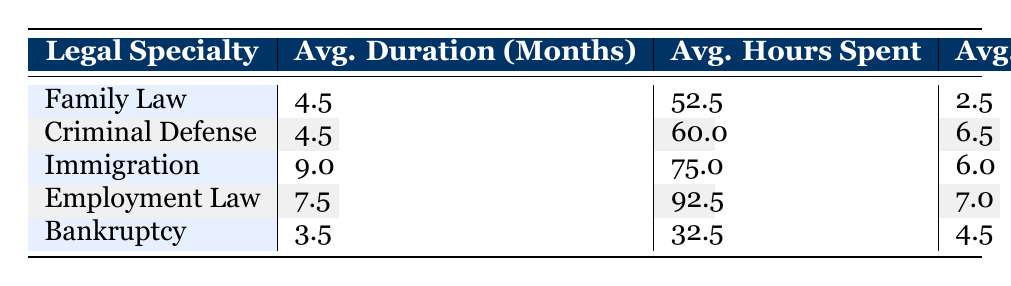What is the average duration of cases in Family Law? There are two Family Law cases. The average duration is calculated by summing their durations (4 + 5 = 9 months) and dividing by the number of cases (9 / 2 = 4.5 months).
Answer: 4.5 months What is the total number of cases handled in Immigration Law? There are two cases listed under Immigration Law: PB003 and PB008, which are the only cases in that specialty. Therefore, the total is 2.
Answer: 2 Which legal specialty has the lowest average hours spent on cases? By examining the average hours spent for each specialty: Family Law (52.5), Criminal Defense (60.0), Immigration (75.0), Employment Law (92.5), and Bankruptcy (32.5), it's clear that Bankruptcy has the lowest average at 32.5 hours.
Answer: Bankruptcy Is the percentage of favorable outcomes higher in Criminal Defense compared to Family Law? In Criminal Defense, there are 2 cases, both of which have favorable outcomes, resulting in 100%. In Family Law, 1 out of 2 cases is favorable, leading to 50%. Since 100% is greater than 50%, the answer is yes.
Answer: Yes What is the overall average lawyer experience for all specialties included in the table? To find the overall average experience, sum the experience of all lawyers (2.5 + 6.5 + 6.0 + 7.0 + 4.5) = 26.5 years and divide by the number of specialties (5), resulting in 26.5 / 5 = 5.3 years.
Answer: 5.3 years Which legal specialty has the highest percentage of favorable outcomes? Analyzing the data, Criminal Defense, Immigration, and Bankruptcy all have favorable outcomes of 100%, while Family Law and Employment Law only have 50%. Therefore, the specialties with the highest percentage of favorable outcomes are Criminal Defense, Immigration, and Bankruptcy.
Answer: Criminal Defense, Immigration, Bankruptcy What is the average duration of cases in Employment Law compared to Bankruptcy? The average duration for Employment Law is 7.5 months, and for Bankruptcy, it is 3.5 months. Comparing these, Employment Law has a longer average duration than Bankruptcy, showing (7.5 vs 3.5).
Answer: Employment Law has a longer average duration Are there any cases in the table with an unfavorable outcome? There is one case from Employment Law (PB009) that shows an unfavorable outcome, as indicated in the data. Therefore, the answer is affirmative.
Answer: Yes 